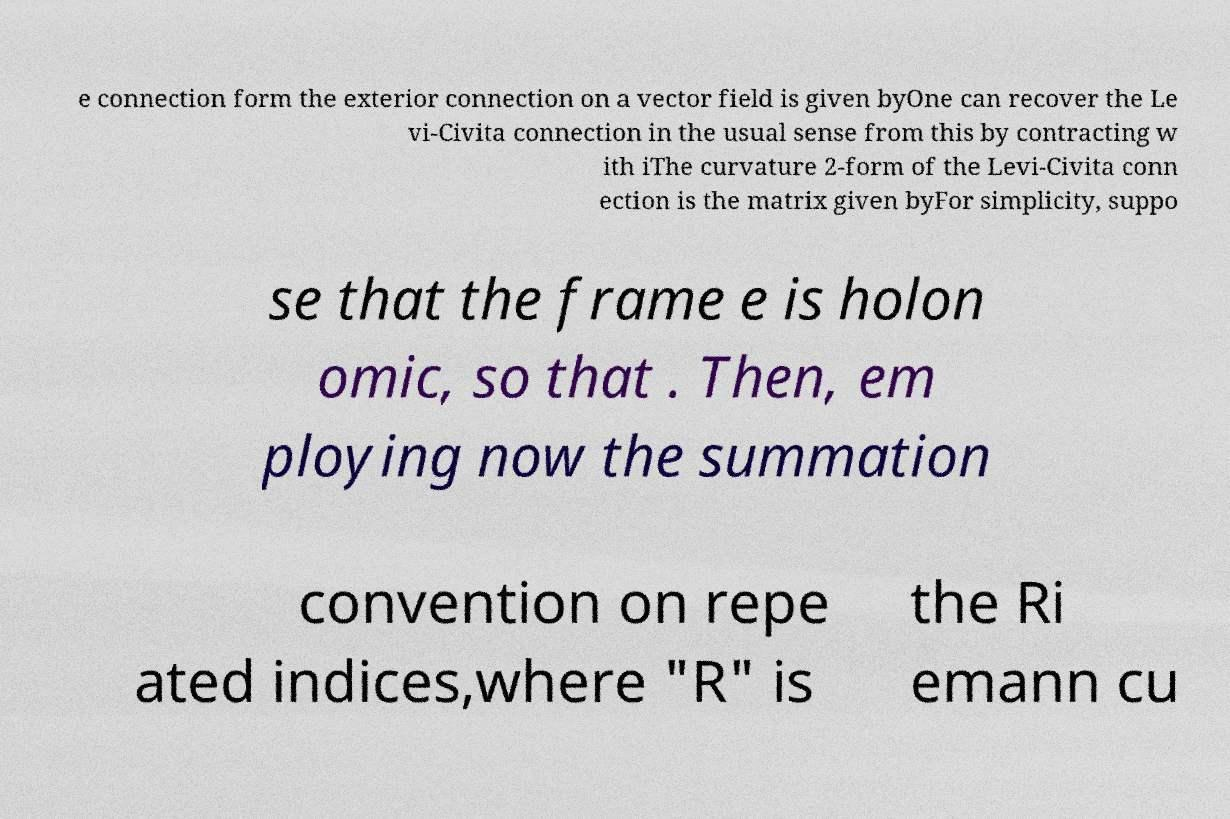Can you accurately transcribe the text from the provided image for me? e connection form the exterior connection on a vector field is given byOne can recover the Le vi-Civita connection in the usual sense from this by contracting w ith iThe curvature 2-form of the Levi-Civita conn ection is the matrix given byFor simplicity, suppo se that the frame e is holon omic, so that . Then, em ploying now the summation convention on repe ated indices,where "R" is the Ri emann cu 